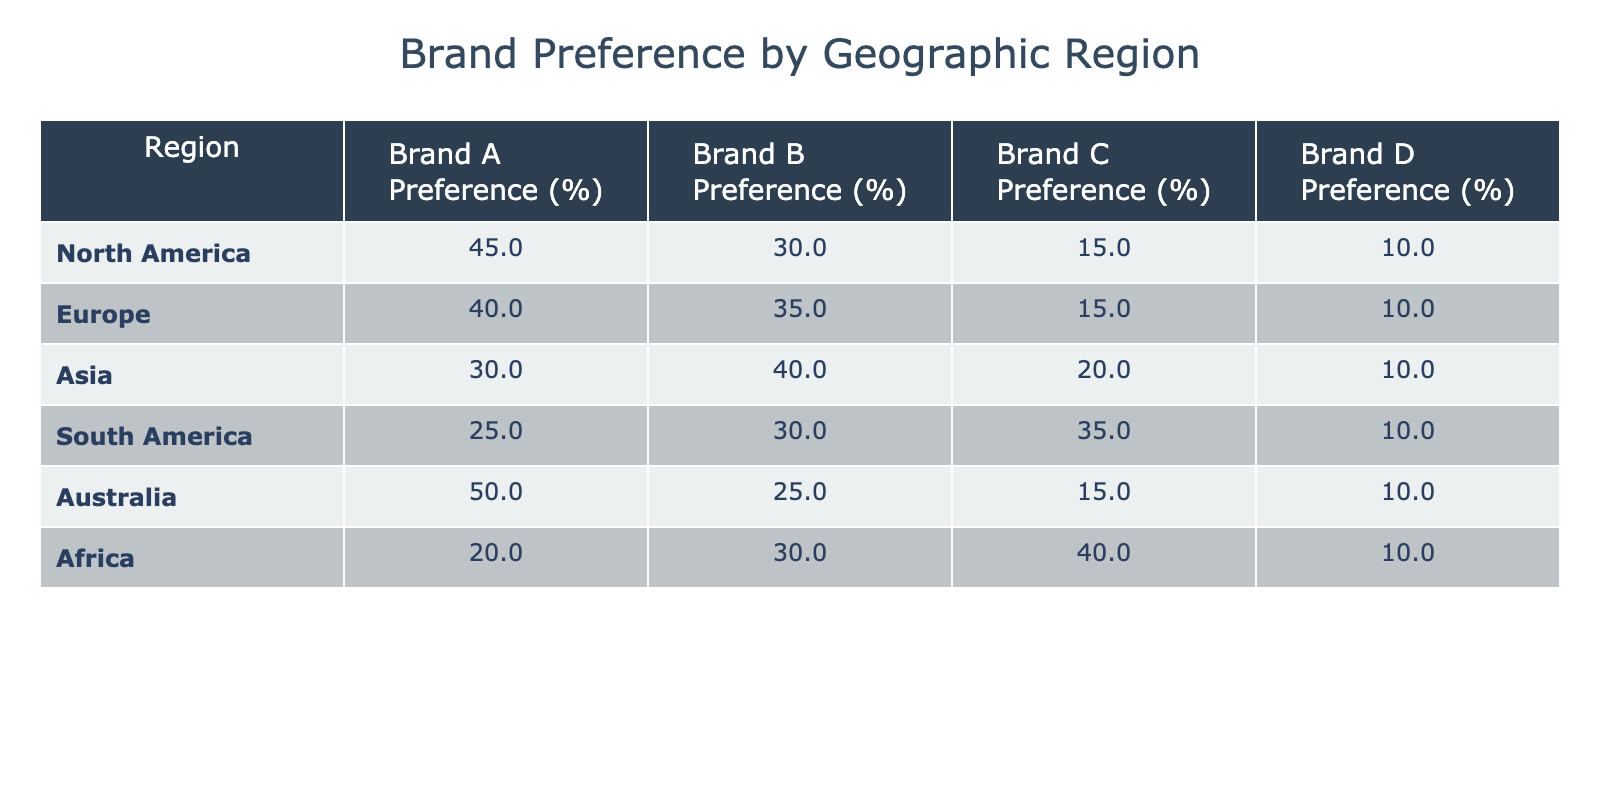What is the brand preference percentage for Brand A in North America? According to the table, the brand preference percentage for Brand A in North America is explicitly listed as 45%.
Answer: 45% Which brand has the highest preference percentage in Asia? In the Asia row of the table, Brand B has the highest percentage at 40%, compared to the other brands.
Answer: Brand B What is the average brand preference percentage for Brand C across all regions? The brand preference percentages for Brand C in the regions are 15, 15, 20, 35, 15, and 40. To find the average, we sum these values: 15 + 15 + 20 + 35 + 15 + 40 = 140. Then, divide by the number of regions (6), which gives us 140 / 6 = approximately 23.33.
Answer: 23.33 Is there any region where Brand D has a preference percentage greater than 15%? By examining the percentages for Brand D across all regions, we see that Brand D has a preference percentage of only 10% in every region. Thus, there are no regions with a percentage greater than 15%.
Answer: No What is the difference in brand preference percentages for Brand A between North America and Europe? To find the difference, subtract the preference percentage for Brand A in Europe (40%) from that in North America (45%): 45 - 40 = 5. Therefore, Brand A is 5% more preferred in North America compared to Europe.
Answer: 5 Which brand has the lowest preference percentage overall? By checking each brand's preference across all regions, we can see that Brand D has the lowest preference, remaining at 10% in every region, while other brands have higher percentages.
Answer: Brand D What is the total brand preference percentage for Brand C in South America and Africa combined? The preference for Brand C in South America is 35% and in Africa is 40%. To find the total, add these two values: 35 + 40 = 75. Therefore, the total preference percentage for Brand C in the two regions combined is 75%.
Answer: 75% Which brand is preferred the most in Australia based on the table? In the Australia row, Brand A shows the highest preference percentage at 50%, compared to the preferences for other brands.
Answer: Brand A How does the preference percentage for Brand B in Europe compare to that in South America? The preference percentage for Brand B in Europe is 35%, while in South America it is 30%. Thus, Brand B is 5% more preferred in Europe than in South America.
Answer: 5% more in Europe 